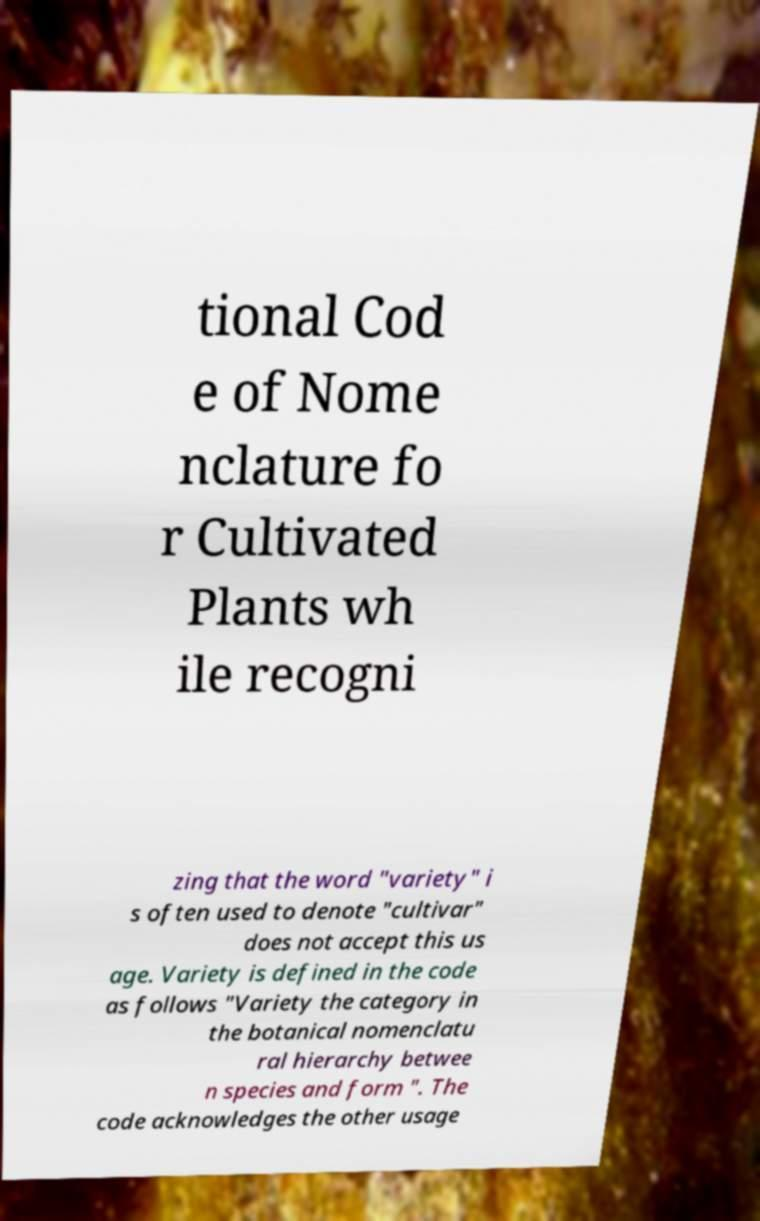I need the written content from this picture converted into text. Can you do that? tional Cod e of Nome nclature fo r Cultivated Plants wh ile recogni zing that the word "variety" i s often used to denote "cultivar" does not accept this us age. Variety is defined in the code as follows "Variety the category in the botanical nomenclatu ral hierarchy betwee n species and form ". The code acknowledges the other usage 